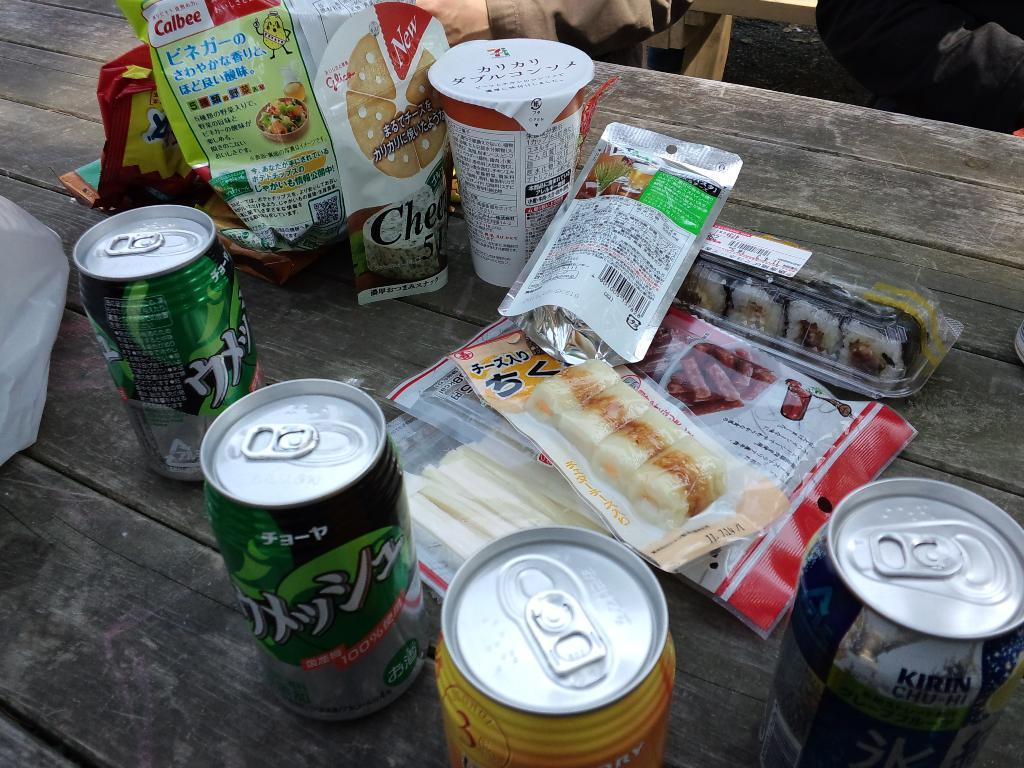<image>
Summarize the visual content of the image. A can of Kirin Chu-Hi is among the food and beverages on the wood table. 